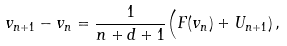<formula> <loc_0><loc_0><loc_500><loc_500>v _ { n + 1 } - v _ { n } & = \frac { 1 } { n + d + 1 } \Big ( F ( v _ { n } ) + U _ { n + 1 } ) \, ,</formula> 